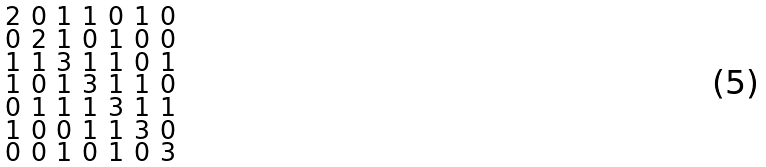Convert formula to latex. <formula><loc_0><loc_0><loc_500><loc_500>\begin{smallmatrix} 2 & 0 & 1 & 1 & 0 & 1 & 0 \\ 0 & 2 & 1 & 0 & 1 & 0 & 0 \\ 1 & 1 & 3 & 1 & 1 & 0 & 1 \\ 1 & 0 & 1 & 3 & 1 & 1 & 0 \\ 0 & 1 & 1 & 1 & 3 & 1 & 1 \\ 1 & 0 & 0 & 1 & 1 & 3 & 0 \\ 0 & 0 & 1 & 0 & 1 & 0 & 3 \end{smallmatrix}</formula> 